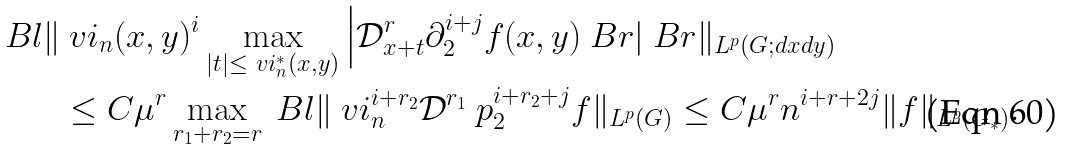Convert formula to latex. <formula><loc_0><loc_0><loc_500><loc_500>\ B l \| & \ v i _ { n } ( x , y ) ^ { i } \max _ { | t | \leq \ v i ^ { \ast } _ { n } ( x , y ) } \Big | { \mathcal { D } } _ { x + t } ^ { r } \partial _ { 2 } ^ { i + j } f ( x , y ) \ B r | \ B r \| _ { L ^ { p } ( G ; d x d y ) } \\ & \leq C \mu ^ { r } \max _ { r _ { 1 } + r _ { 2 } = r } \ B l \| \ v i _ { n } ^ { i + r _ { 2 } } { \mathcal { D } } ^ { r _ { 1 } } \ p _ { 2 } ^ { i + r _ { 2 } + j } f \| _ { L ^ { p } ( G ) } \leq C \mu ^ { r } n ^ { i + r + 2 j } \| f \| _ { L ^ { p } ( G _ { \ast } ) } .</formula> 